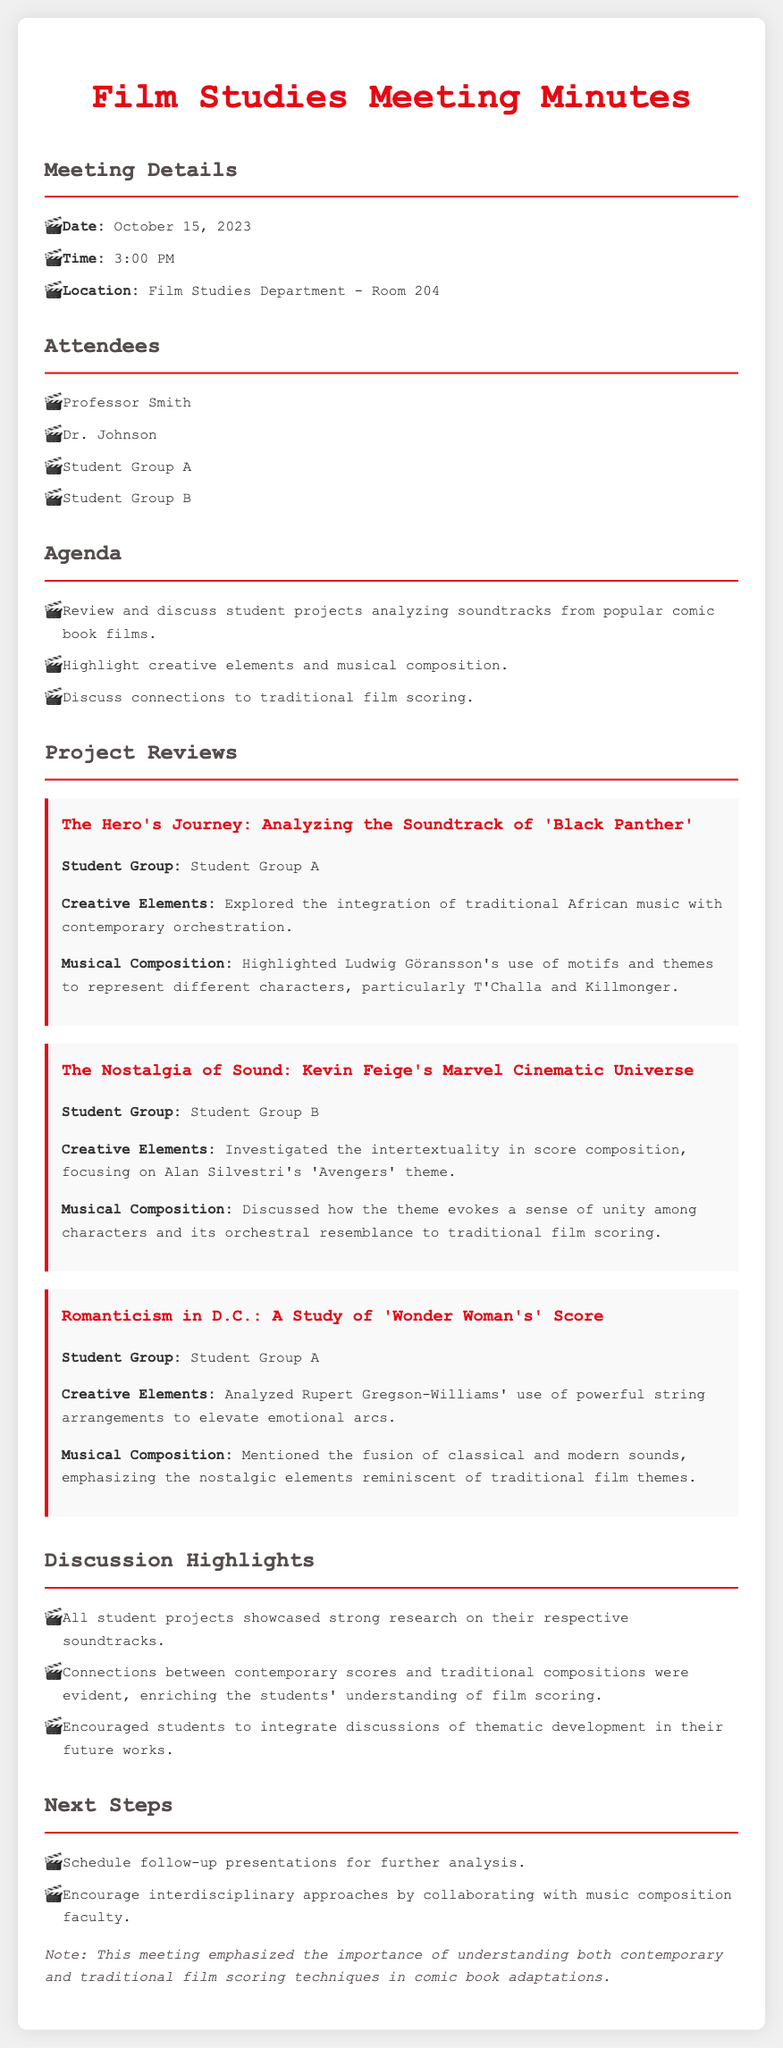what is the date of the meeting? The date is explicitly mentioned in the meeting details section of the document.
Answer: October 15, 2023 who presented the project on 'Black Panther'? The student group responsible for the project is specified in the project reviews section.
Answer: Student Group A what key theme did Student Group B investigate? The theme being analyzed is highlighted in their project review, focusing on score composition.
Answer: intertextuality how many student groups attended the meeting? The number of student groups can be counted from the attendees list.
Answer: 2 which composer’s work did the project on 'Wonder Woman' highlight? The composer's name is noted in the project review concerning 'Wonder Woman'.
Answer: Rupert Gregson-Williams what element of musical composition was emphasized in the discussion highlights? The specific element they encouraged students to integrate into their future works is stated.
Answer: thematic development which score theme was discussed in relation to the sense of unity? The discussed theme is mentioned explicitly in the project review by Student Group B.
Answer: 'Avengers' theme 